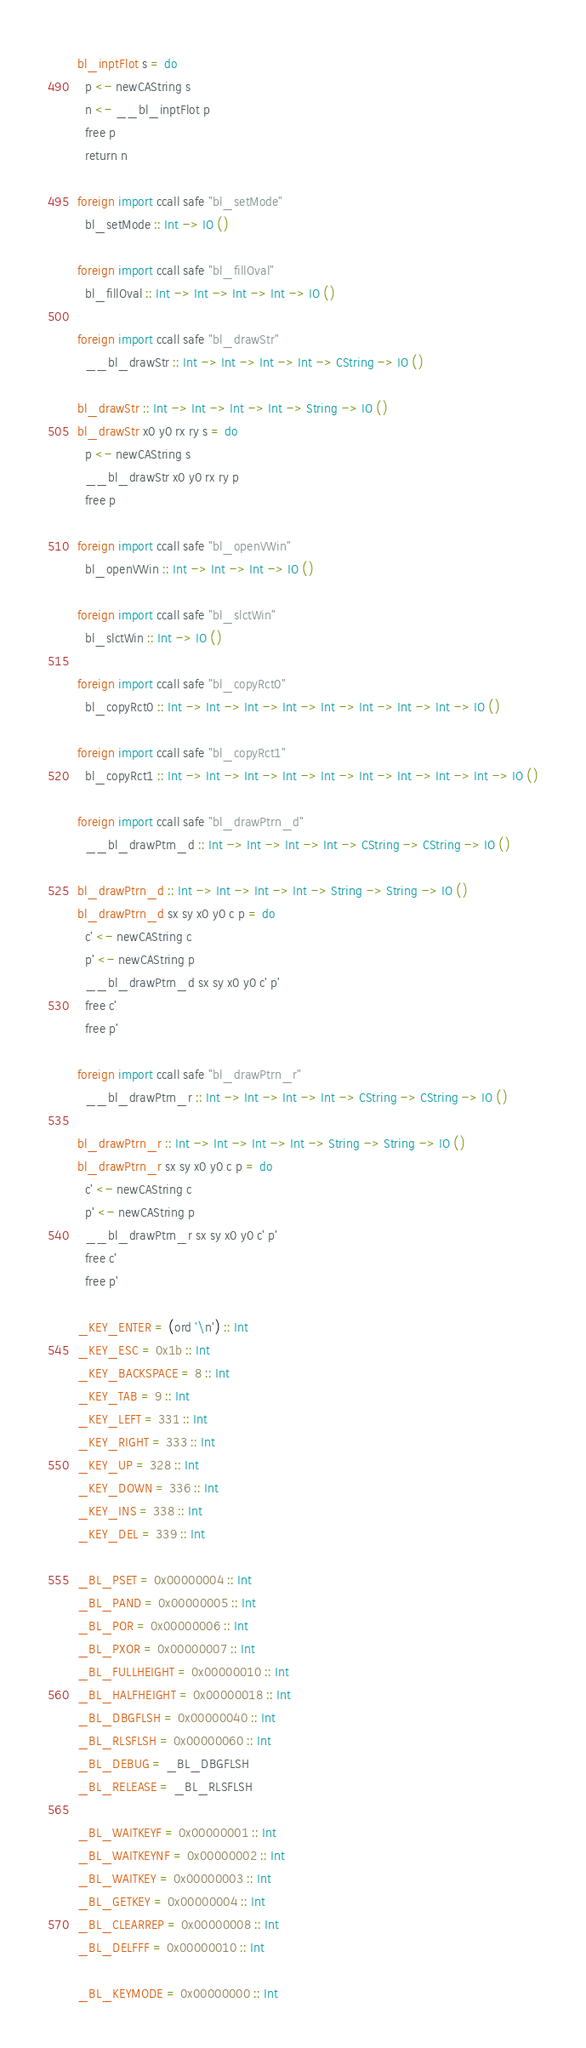Convert code to text. <code><loc_0><loc_0><loc_500><loc_500><_Haskell_>bl_inptFlot s = do
  p <- newCAString s
  n <- __bl_inptFlot p
  free p
  return n

foreign import ccall safe "bl_setMode"
  bl_setMode :: Int -> IO ()

foreign import ccall safe "bl_fillOval"
  bl_fillOval :: Int -> Int -> Int -> Int -> IO ()

foreign import ccall safe "bl_drawStr"
  __bl_drawStr :: Int -> Int -> Int -> Int -> CString -> IO ()

bl_drawStr :: Int -> Int -> Int -> Int -> String -> IO ()
bl_drawStr x0 y0 rx ry s = do
  p <- newCAString s
  __bl_drawStr x0 y0 rx ry p
  free p

foreign import ccall safe "bl_openVWin"
  bl_openVWin :: Int -> Int -> Int -> IO ()

foreign import ccall safe "bl_slctWin"
  bl_slctWin :: Int -> IO ()

foreign import ccall safe "bl_copyRct0"
  bl_copyRct0 :: Int -> Int -> Int -> Int -> Int -> Int -> Int -> Int -> IO ()

foreign import ccall safe "bl_copyRct1"
  bl_copyRct1 :: Int -> Int -> Int -> Int -> Int -> Int -> Int -> Int -> Int -> IO ()

foreign import ccall safe "bl_drawPtrn_d"
  __bl_drawPtrn_d :: Int -> Int -> Int -> Int -> CString -> CString -> IO ()

bl_drawPtrn_d :: Int -> Int -> Int -> Int -> String -> String -> IO ()
bl_drawPtrn_d sx sy x0 y0 c p = do
  c' <- newCAString c
  p' <- newCAString p
  __bl_drawPtrn_d sx sy x0 y0 c' p'
  free c'
  free p'

foreign import ccall safe "bl_drawPtrn_r"
  __bl_drawPtrn_r :: Int -> Int -> Int -> Int -> CString -> CString -> IO ()

bl_drawPtrn_r :: Int -> Int -> Int -> Int -> String -> String -> IO ()
bl_drawPtrn_r sx sy x0 y0 c p = do
  c' <- newCAString c
  p' <- newCAString p
  __bl_drawPtrn_r sx sy x0 y0 c' p'
  free c'
  free p'

_KEY_ENTER = (ord '\n') :: Int
_KEY_ESC = 0x1b :: Int
_KEY_BACKSPACE = 8 :: Int
_KEY_TAB = 9 :: Int
_KEY_LEFT = 331 :: Int
_KEY_RIGHT = 333 :: Int
_KEY_UP = 328 :: Int
_KEY_DOWN = 336 :: Int
_KEY_INS = 338 :: Int
_KEY_DEL = 339 :: Int

_BL_PSET = 0x00000004 :: Int
_BL_PAND = 0x00000005 :: Int
_BL_POR = 0x00000006 :: Int
_BL_PXOR = 0x00000007 :: Int
_BL_FULLHEIGHT = 0x00000010 :: Int
_BL_HALFHEIGHT = 0x00000018 :: Int
_BL_DBGFLSH = 0x00000040 :: Int
_BL_RLSFLSH = 0x00000060 :: Int
_BL_DEBUG = _BL_DBGFLSH
_BL_RELEASE = _BL_RLSFLSH

_BL_WAITKEYF = 0x00000001 :: Int
_BL_WAITKEYNF = 0x00000002 :: Int
_BL_WAITKEY = 0x00000003 :: Int
_BL_GETKEY = 0x00000004 :: Int
_BL_CLEARREP = 0x00000008 :: Int
_BL_DELFFF = 0x00000010 :: Int

_BL_KEYMODE = 0x00000000 :: Int
</code> 